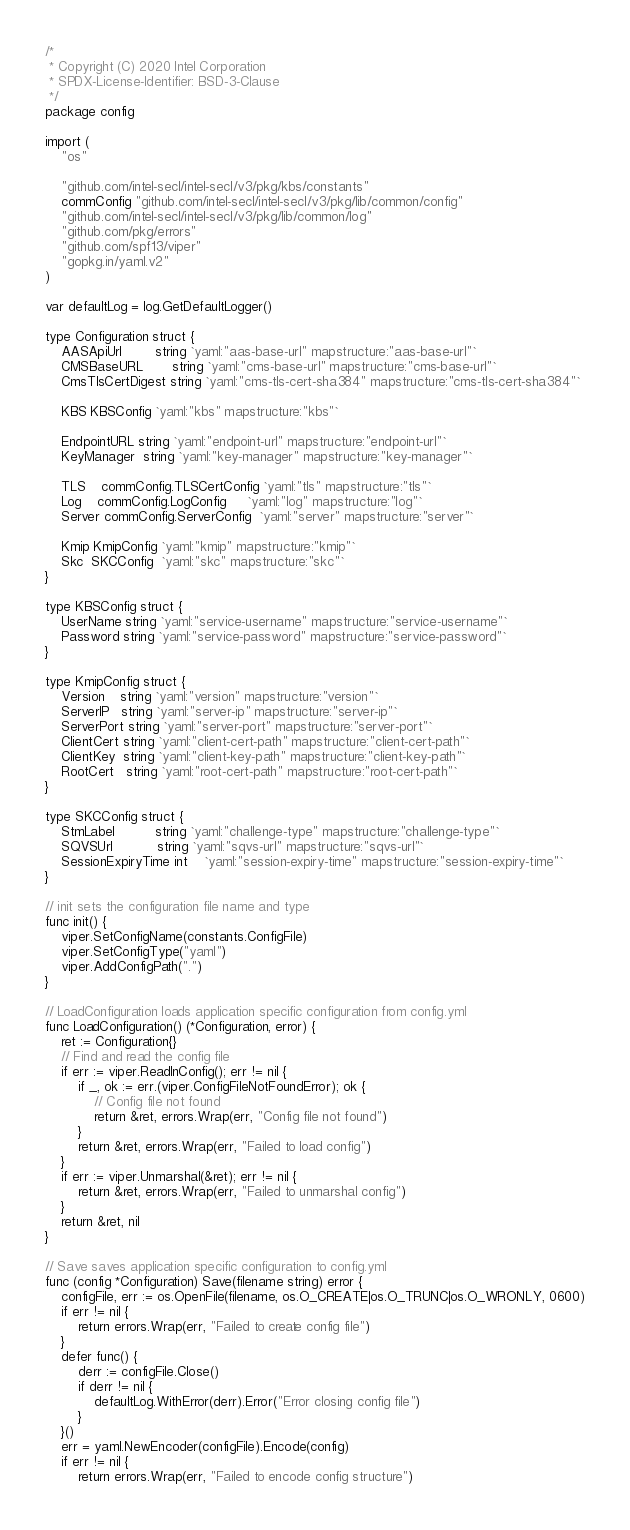<code> <loc_0><loc_0><loc_500><loc_500><_Go_>/*
 * Copyright (C) 2020 Intel Corporation
 * SPDX-License-Identifier: BSD-3-Clause
 */
package config

import (
	"os"

	"github.com/intel-secl/intel-secl/v3/pkg/kbs/constants"
	commConfig "github.com/intel-secl/intel-secl/v3/pkg/lib/common/config"
	"github.com/intel-secl/intel-secl/v3/pkg/lib/common/log"
	"github.com/pkg/errors"
	"github.com/spf13/viper"
	"gopkg.in/yaml.v2"
)

var defaultLog = log.GetDefaultLogger()

type Configuration struct {
	AASApiUrl        string `yaml:"aas-base-url" mapstructure:"aas-base-url"`
	CMSBaseURL       string `yaml:"cms-base-url" mapstructure:"cms-base-url"`
	CmsTlsCertDigest string `yaml:"cms-tls-cert-sha384" mapstructure:"cms-tls-cert-sha384"`

	KBS KBSConfig `yaml:"kbs" mapstructure:"kbs"`

	EndpointURL string `yaml:"endpoint-url" mapstructure:"endpoint-url"`
	KeyManager  string `yaml:"key-manager" mapstructure:"key-manager"`

	TLS    commConfig.TLSCertConfig `yaml:"tls" mapstructure:"tls"`
	Log    commConfig.LogConfig     `yaml:"log" mapstructure:"log"`
	Server commConfig.ServerConfig  `yaml:"server" mapstructure:"server"`

	Kmip KmipConfig `yaml:"kmip" mapstructure:"kmip"`
	Skc  SKCConfig  `yaml:"skc" mapstructure:"skc"`
}

type KBSConfig struct {
	UserName string `yaml:"service-username" mapstructure:"service-username"`
	Password string `yaml:"service-password" mapstructure:"service-password"`
}

type KmipConfig struct {
	Version    string `yaml:"version" mapstructure:"version"`
	ServerIP   string `yaml:"server-ip" mapstructure:"server-ip"`
	ServerPort string `yaml:"server-port" mapstructure:"server-port"`
	ClientCert string `yaml:"client-cert-path" mapstructure:"client-cert-path"`
	ClientKey  string `yaml:"client-key-path" mapstructure:"client-key-path"`
	RootCert   string `yaml:"root-cert-path" mapstructure:"root-cert-path"`
}

type SKCConfig struct {
	StmLabel          string `yaml:"challenge-type" mapstructure:"challenge-type"`
	SQVSUrl           string `yaml:"sqvs-url" mapstructure:"sqvs-url"`
	SessionExpiryTime int    `yaml:"session-expiry-time" mapstructure:"session-expiry-time"`
}

// init sets the configuration file name and type
func init() {
	viper.SetConfigName(constants.ConfigFile)
	viper.SetConfigType("yaml")
	viper.AddConfigPath(".")
}

// LoadConfiguration loads application specific configuration from config.yml
func LoadConfiguration() (*Configuration, error) {
	ret := Configuration{}
	// Find and read the config file
	if err := viper.ReadInConfig(); err != nil {
		if _, ok := err.(viper.ConfigFileNotFoundError); ok {
			// Config file not found
			return &ret, errors.Wrap(err, "Config file not found")
		}
		return &ret, errors.Wrap(err, "Failed to load config")
	}
	if err := viper.Unmarshal(&ret); err != nil {
		return &ret, errors.Wrap(err, "Failed to unmarshal config")
	}
	return &ret, nil
}

// Save saves application specific configuration to config.yml
func (config *Configuration) Save(filename string) error {
	configFile, err := os.OpenFile(filename, os.O_CREATE|os.O_TRUNC|os.O_WRONLY, 0600)
	if err != nil {
		return errors.Wrap(err, "Failed to create config file")
	}
	defer func() {
		derr := configFile.Close()
		if derr != nil {
			defaultLog.WithError(derr).Error("Error closing config file")
		}
	}()
	err = yaml.NewEncoder(configFile).Encode(config)
	if err != nil {
		return errors.Wrap(err, "Failed to encode config structure")</code> 